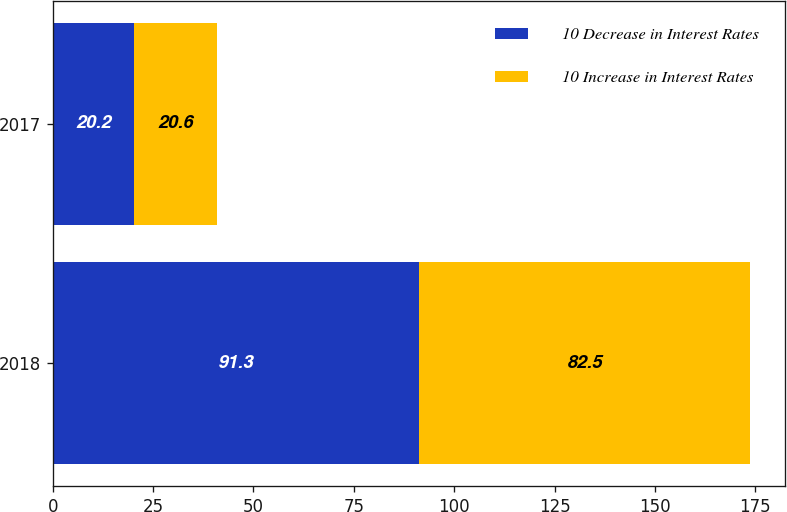<chart> <loc_0><loc_0><loc_500><loc_500><stacked_bar_chart><ecel><fcel>2018<fcel>2017<nl><fcel>10 Decrease in Interest Rates<fcel>91.3<fcel>20.2<nl><fcel>10 Increase in Interest Rates<fcel>82.5<fcel>20.6<nl></chart> 